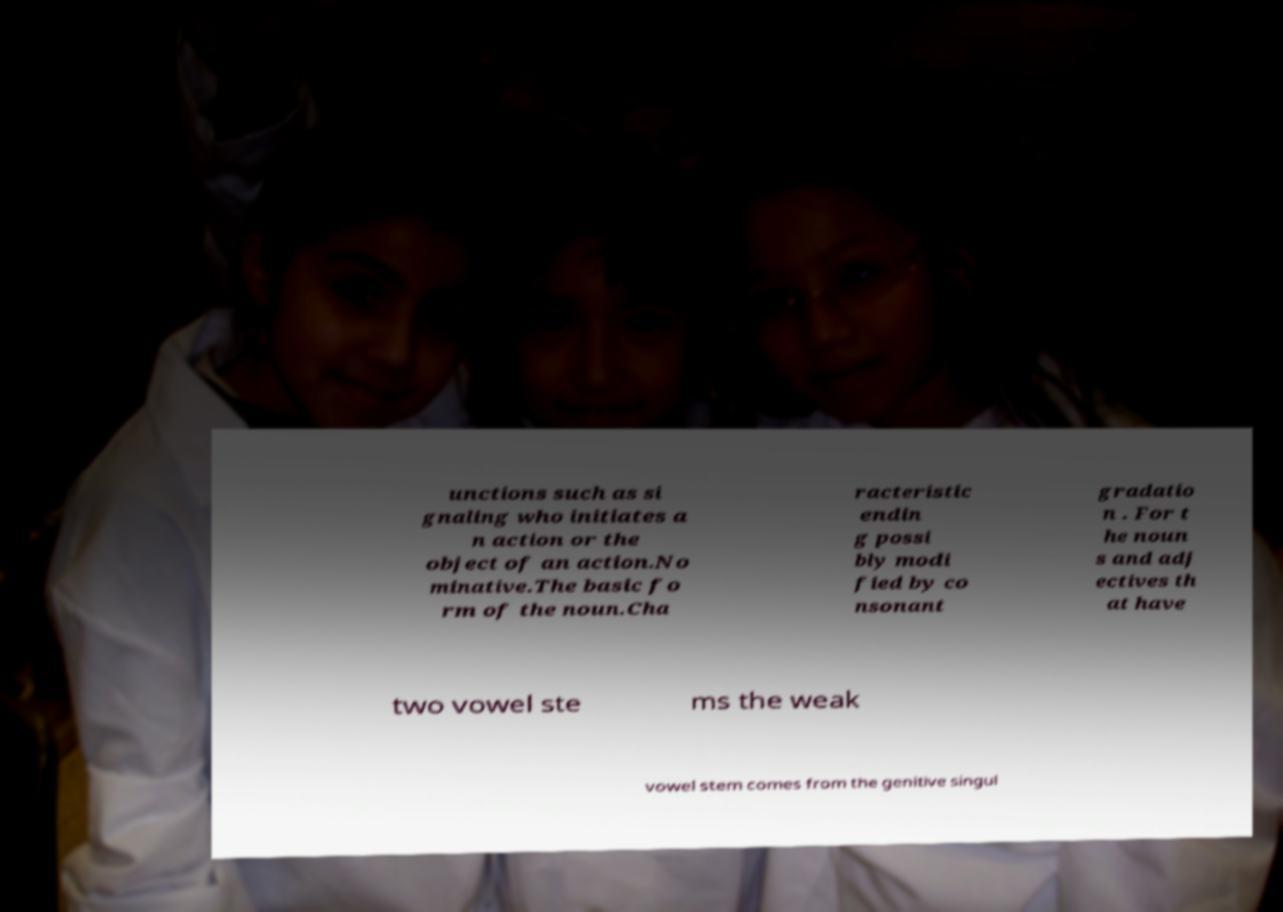Please identify and transcribe the text found in this image. unctions such as si gnaling who initiates a n action or the object of an action.No minative.The basic fo rm of the noun.Cha racteristic endin g possi bly modi fied by co nsonant gradatio n . For t he noun s and adj ectives th at have two vowel ste ms the weak vowel stem comes from the genitive singul 